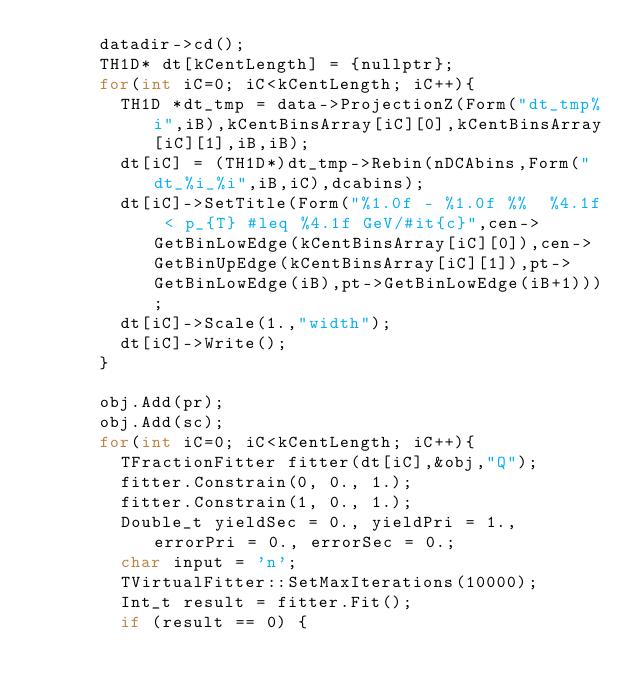<code> <loc_0><loc_0><loc_500><loc_500><_C++_>      datadir->cd();
      TH1D* dt[kCentLength] = {nullptr};
      for(int iC=0; iC<kCentLength; iC++){
        TH1D *dt_tmp = data->ProjectionZ(Form("dt_tmp%i",iB),kCentBinsArray[iC][0],kCentBinsArray[iC][1],iB,iB);
        dt[iC] = (TH1D*)dt_tmp->Rebin(nDCAbins,Form("dt_%i_%i",iB,iC),dcabins);
        dt[iC]->SetTitle(Form("%1.0f - %1.0f %%  %4.1f < p_{T} #leq %4.1f GeV/#it{c}",cen->GetBinLowEdge(kCentBinsArray[iC][0]),cen->GetBinUpEdge(kCentBinsArray[iC][1]),pt->GetBinLowEdge(iB),pt->GetBinLowEdge(iB+1)));
        dt[iC]->Scale(1.,"width");
        dt[iC]->Write();
      }

      obj.Add(pr);
      obj.Add(sc);
      for(int iC=0; iC<kCentLength; iC++){
        TFractionFitter fitter(dt[iC],&obj,"Q");
        fitter.Constrain(0, 0., 1.);
        fitter.Constrain(1, 0., 1.);
        Double_t yieldSec = 0., yieldPri = 1., errorPri = 0., errorSec = 0.;
        char input = 'n';
        TVirtualFitter::SetMaxIterations(10000);
        Int_t result = fitter.Fit();
        if (result == 0) {</code> 